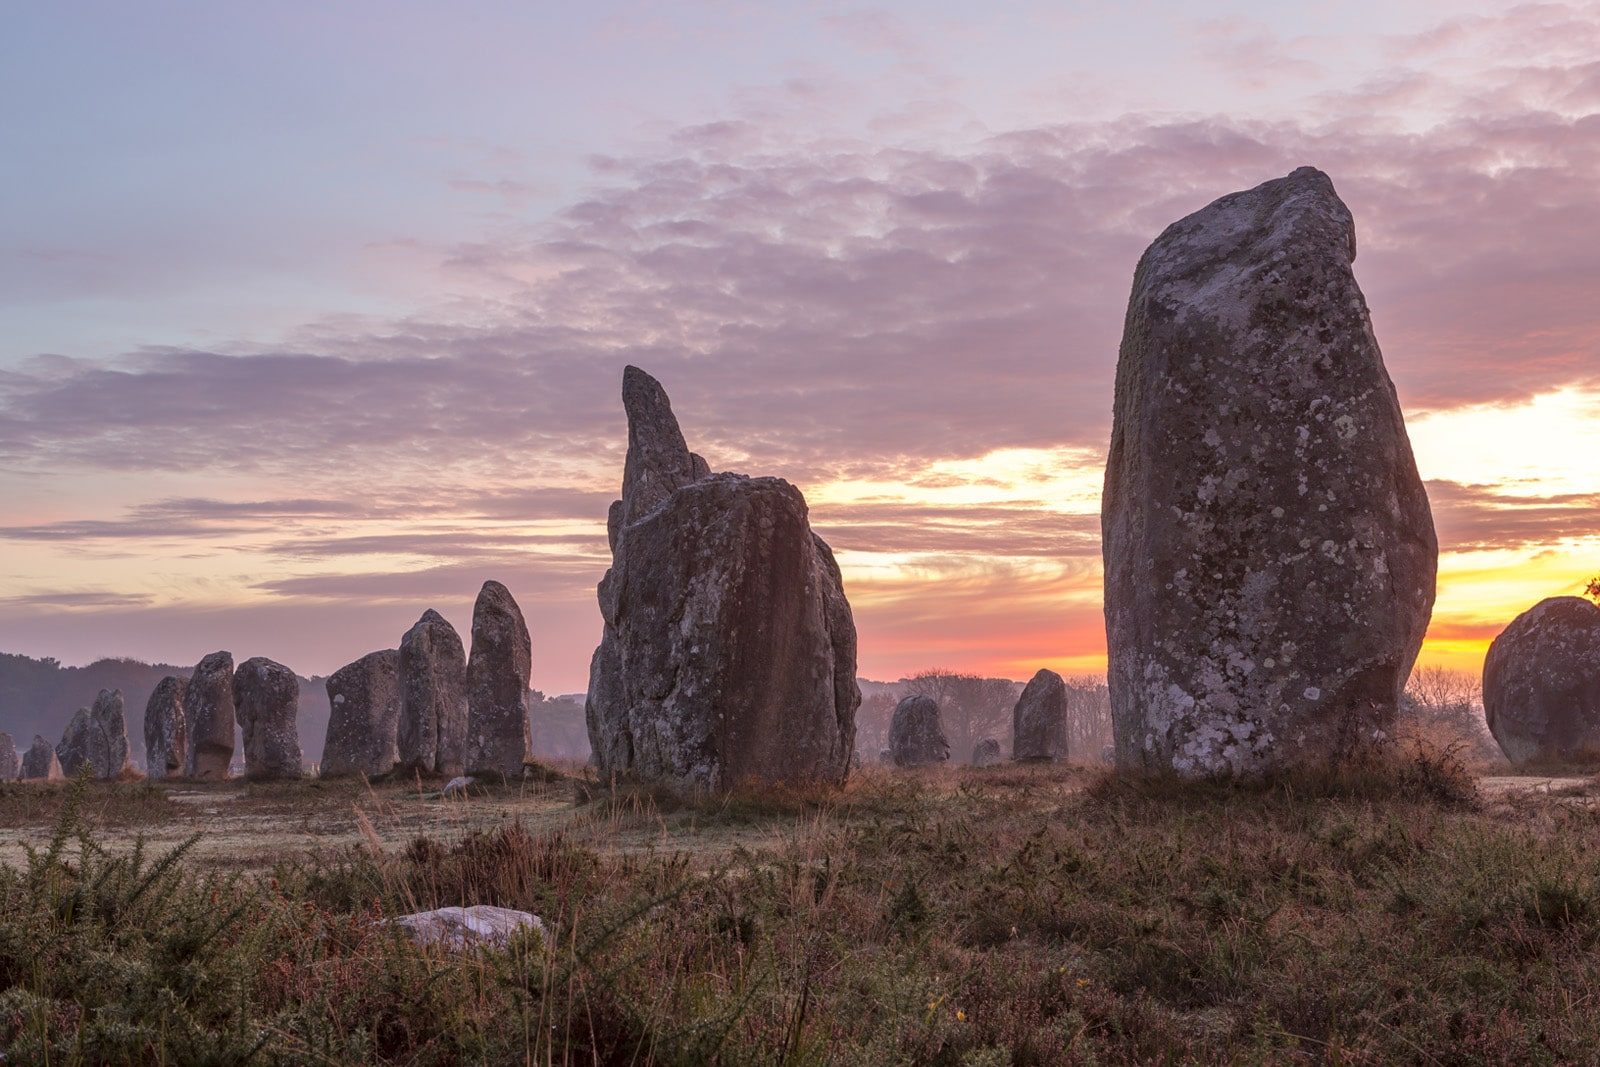Can you tell me more about the history and significance of these stones? The Carnac stones are one of the most extensive Neolithic archaeological sites in the world, dating back to around 3300 BCE. Located in Brittany, France, these stones are arranged in long rows and consist of over 3,000 individual stones. Their exact purpose remains a mystery, but they are believed to have been used for ceremonial or astronomical purposes. The stones vary in size, with some towering over 15 feet tall. The arrangement and sheer number of the stones indicate that the site was of great importance to the prehistoric people who built it. The alignment of the stones is thought to be related to celestial events, suggesting that the site could have been used as a prehistoric observatory or a place of worship. How do these stones compare to other ancient structures like Stonehenge? While both the Carnac stones and Stonehenge are significant megalithic sites from the Neolithic period, they differ in several ways. Stonehenge, located in England, is a circular arrangement of massive stones, some of which are connected by horizontal lintels to form a remarkable trilithon structure. On the other hand, the Carnac stones are primarily set in long, linear rows that stretch over several kilometers. Stonehenge is known for its precise astronomical alignments, marking events such as solstices, and it is believed to have served as a ceremonial or religious site. The Carnac stones' purpose is less clearly defined, but they are thought to be related to celestial events and possibly served a similar ceremonial or religious function. Both sites demonstrate the advanced understanding of geometry and astronomy by their respective ancient cultures. If these stones could tell a story, what do you think they would say? Imagine the ancient whispers in the air as the stones tell their tale—a story of a time long past, of a people deeply connected to the land and the skies above. They would recount the hands that meticulously positioned each stone, guided by an understanding of the stars, seasons, and the cycles of life. The stones would speak of gatherings, rituals, and celebrations held under their shadow, where the dawn's light cast long shadows and the night sky was a tapestry of constellations. They would reveal the awe and reverence early humans felt for the cosmic dance, using these megaliths as markers and beacons in their spiritual and daily lives. The stories would be filled with mystery, wonder, and a profound respect for nature and the universe, echoing the voices of countless generations that have since walked this sacred ground. 